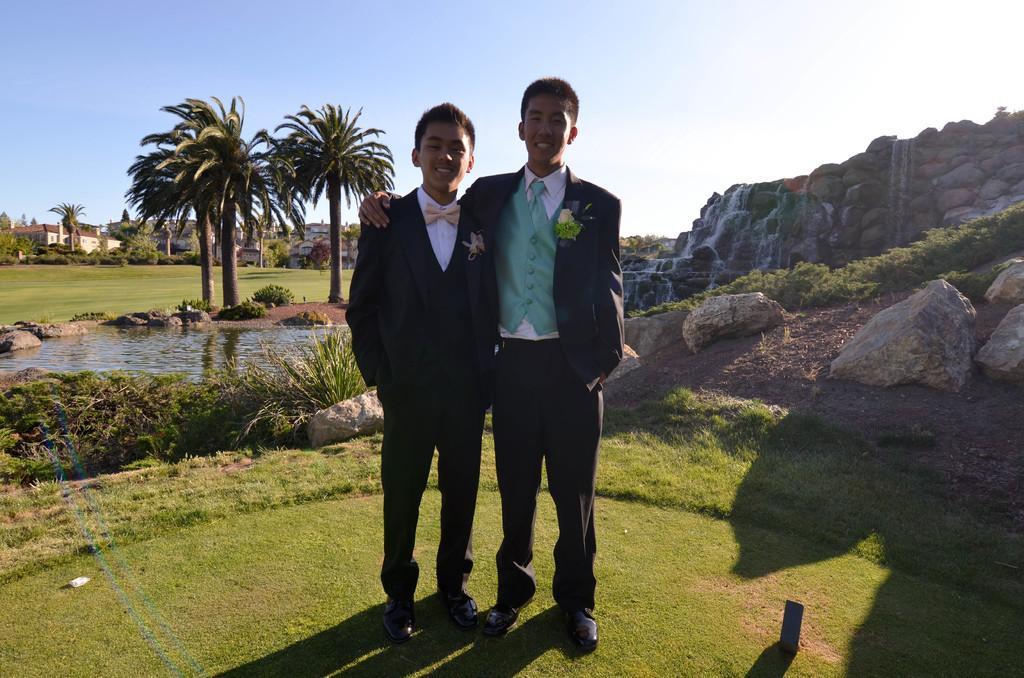Describe this image in one or two sentences. In the image there are two boys standing on the ground and they are smiling. On their dresses there are flowers. On the ground there is grass. On the right side of the image there are rocks on the ground. And also there are small plants. Behind them there are stones with water flowing on it. On the left side of the image there is pound with water. Around the pond there are small plants. In the background there are trees and also there are buildings. At the top of the image there is sky. 